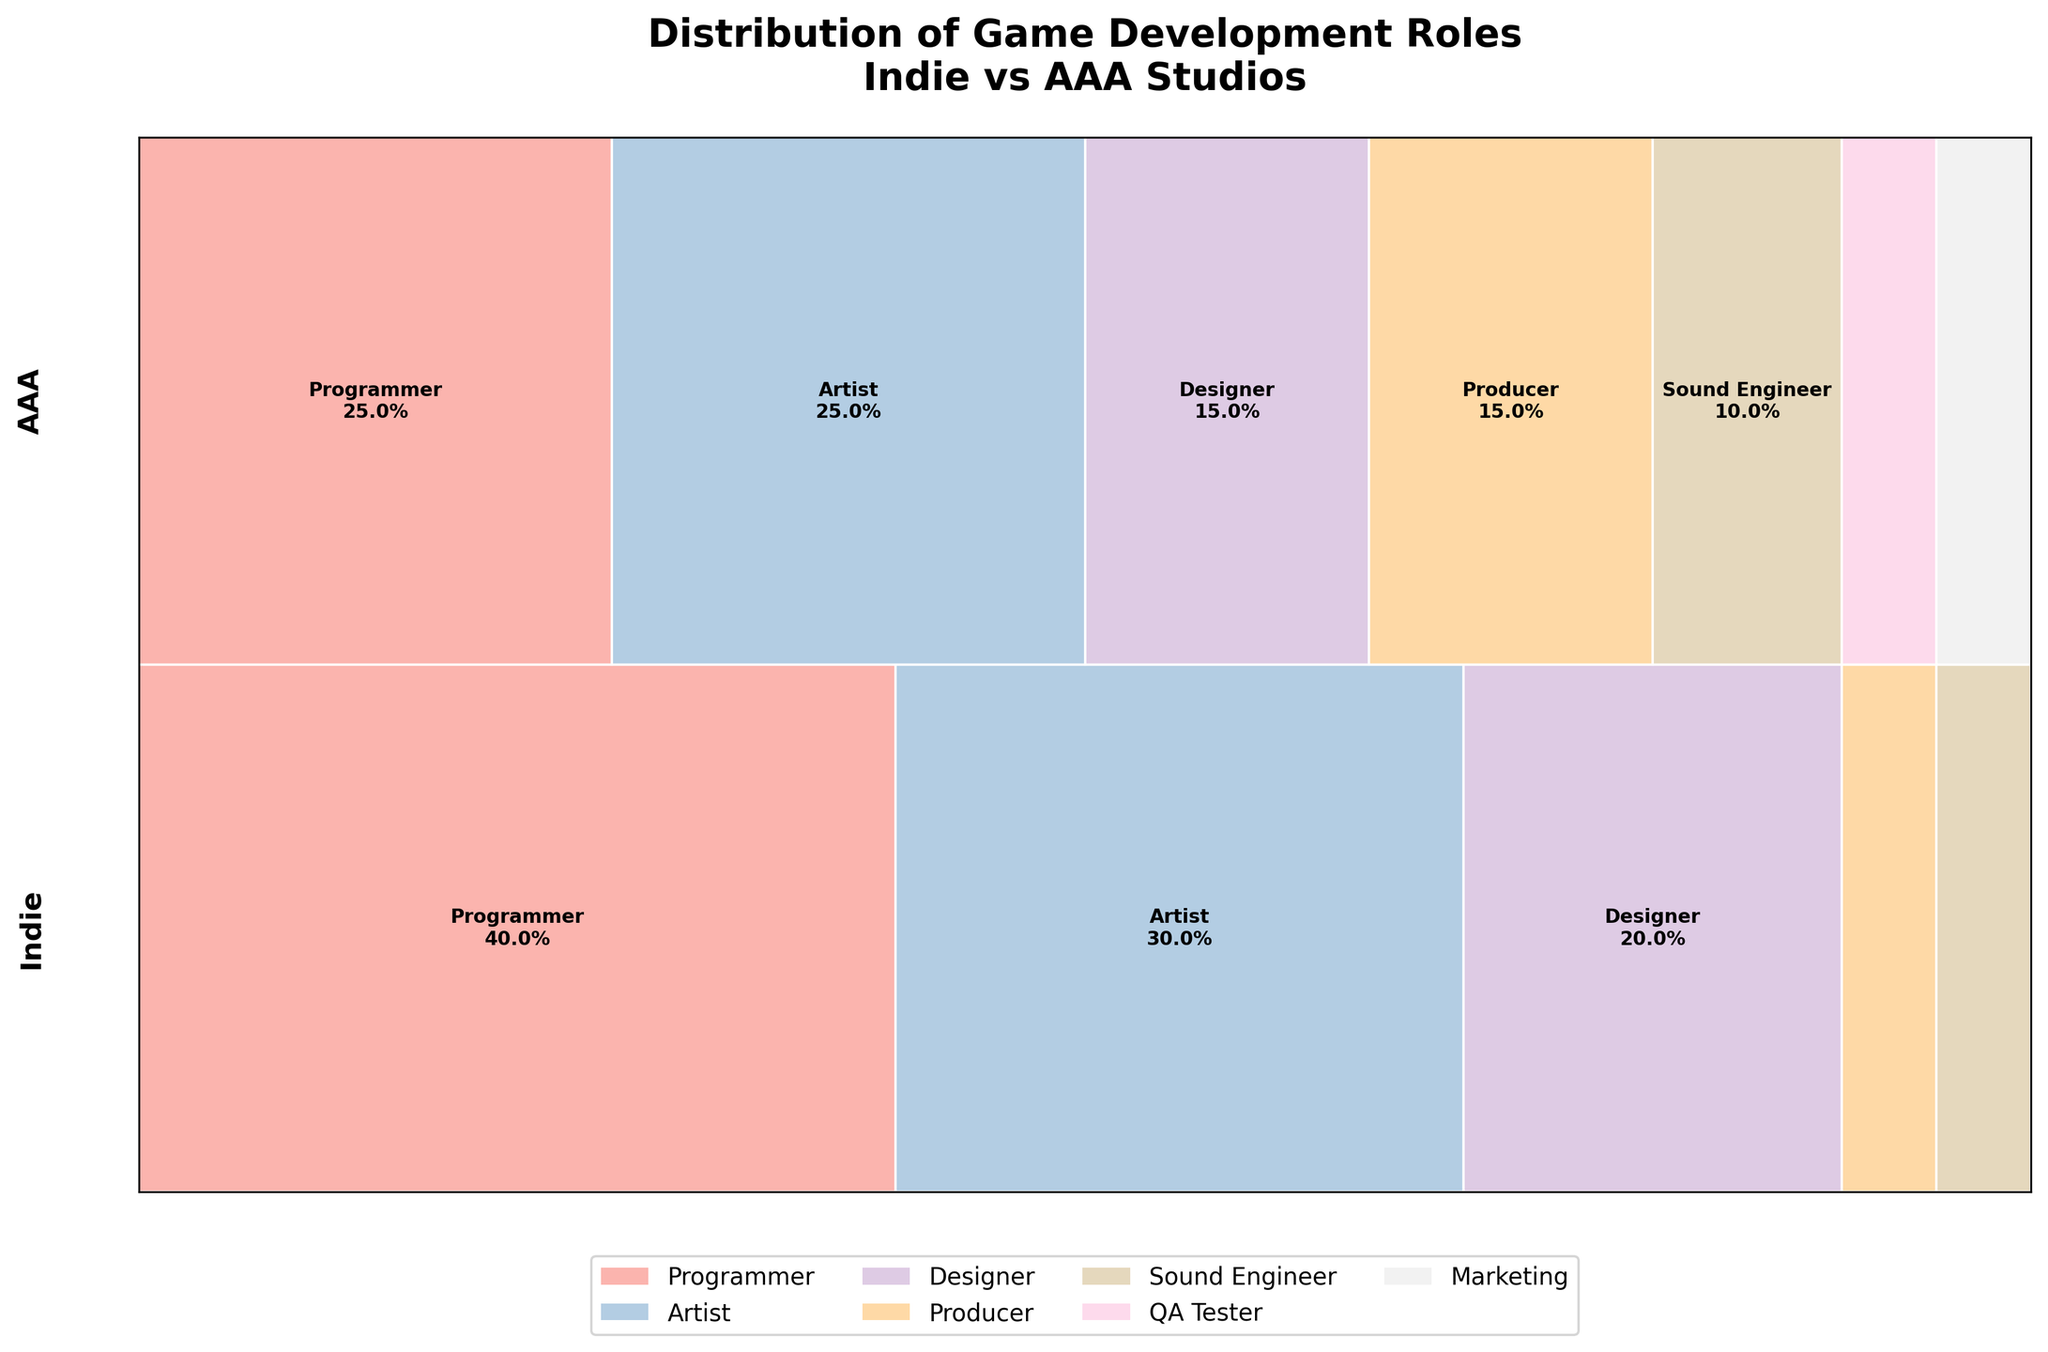What's the title of the figure? The title of the figure is displayed prominently at the top of the plot, usually in a larger and bolder font compared to other text.
Answer: Distribution of Game Development Roles Indie vs AAA Studios Which studio type has a larger portion dedicated to Programmers? Compare the width of the "Programmer" portion between Indie and AAA studios in the plot. The width represents the percentage, and the Indie studio's Programmer section appears wider.
Answer: Indie For AAA studios, which role has the smallest percentage? Look at the AAA studio row and identify the smallest rectangle. The "QA Tester" and "Marketing" roles both have the smallest width.
Answer: QA Tester, Marketing How much wider is the Programmer section in Indie studios compared to AAA studios? Calculate the difference in percentage width of the Programmer section between Indie (40%) and AAA (25%). Subtract 25% from 40% to find the difference.
Answer: 15% Compared to Indie studios, which role is exclusively present in AAA studios but not in Indie studios? Look for the roles listed in the AAA row that do not appear in the Indie row. "QA Tester" and "Marketing" are present only in AAA studios.
Answer: QA Tester, Marketing What's the combined percentage of roles dedicated to Designers and Producers in Indie studios? Add the percentages for Designers (20%) and Producers (5%) in Indie studios: 20% + 5%.
Answer: 25% Which studio type has a greater diversity of roles? Count the number of distinct roles represented in each studio type's row. AAA studios have more roles than Indie studios.
Answer: AAA How does the percentage of Artists in Indie studios compare to those in AAA studios? Compare the width of the "Artist" sections for Indie (30%) and AAA (25%) studios. Indie has a slightly wider "Artist" section.
Answer: Indie has a higher percentage If we sum the percentages of Programmers and Sound Engineers in AAA studios, what fraction of the total is it? Add the percentages for Programmers (25%) and Sound Engineers (10%) in AAA studios: 25% + 10%. This totals 35% of the roles in AAA studios.
Answer: 35% 